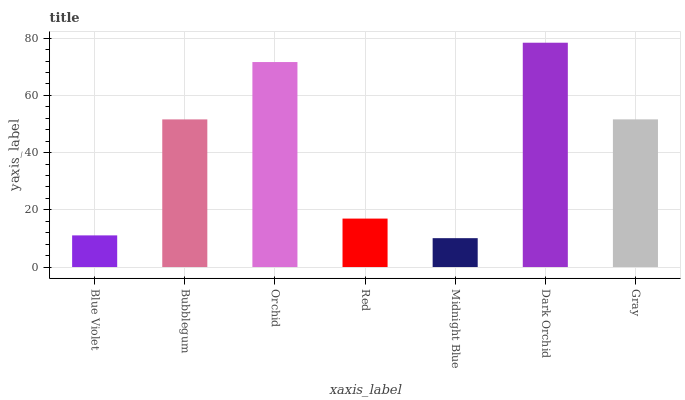Is Midnight Blue the minimum?
Answer yes or no. Yes. Is Dark Orchid the maximum?
Answer yes or no. Yes. Is Bubblegum the minimum?
Answer yes or no. No. Is Bubblegum the maximum?
Answer yes or no. No. Is Bubblegum greater than Blue Violet?
Answer yes or no. Yes. Is Blue Violet less than Bubblegum?
Answer yes or no. Yes. Is Blue Violet greater than Bubblegum?
Answer yes or no. No. Is Bubblegum less than Blue Violet?
Answer yes or no. No. Is Bubblegum the high median?
Answer yes or no. Yes. Is Bubblegum the low median?
Answer yes or no. Yes. Is Orchid the high median?
Answer yes or no. No. Is Orchid the low median?
Answer yes or no. No. 